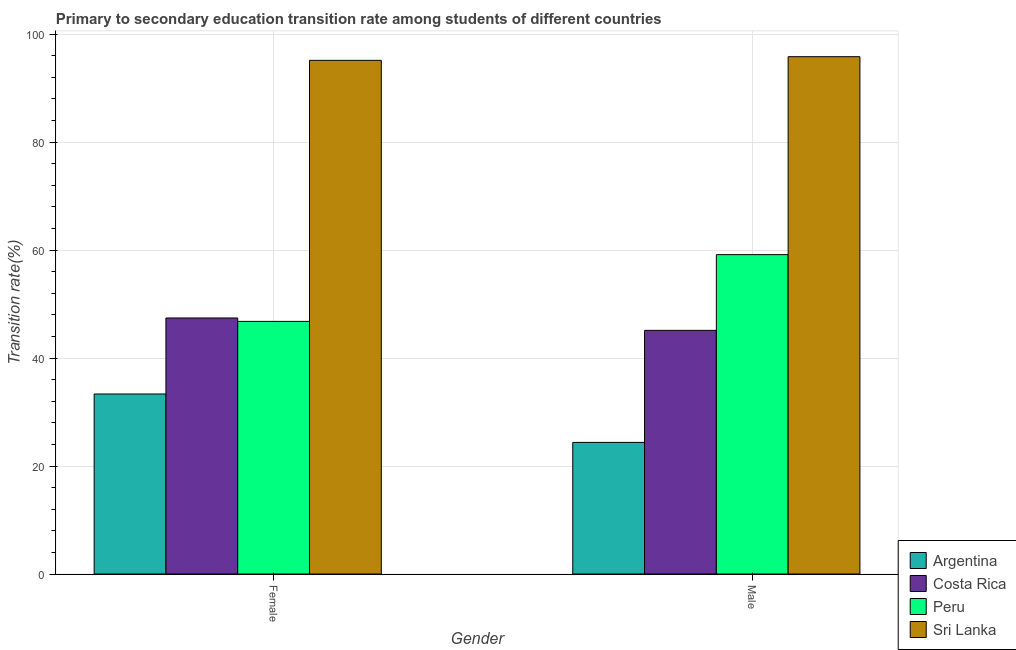How many groups of bars are there?
Give a very brief answer. 2. Are the number of bars per tick equal to the number of legend labels?
Your answer should be compact. Yes. How many bars are there on the 1st tick from the right?
Keep it short and to the point. 4. What is the label of the 2nd group of bars from the left?
Offer a terse response. Male. What is the transition rate among female students in Sri Lanka?
Make the answer very short. 95.13. Across all countries, what is the maximum transition rate among female students?
Offer a very short reply. 95.13. Across all countries, what is the minimum transition rate among female students?
Give a very brief answer. 33.34. In which country was the transition rate among male students maximum?
Provide a short and direct response. Sri Lanka. What is the total transition rate among male students in the graph?
Provide a succinct answer. 224.46. What is the difference between the transition rate among female students in Argentina and that in Sri Lanka?
Provide a short and direct response. -61.79. What is the difference between the transition rate among male students in Costa Rica and the transition rate among female students in Sri Lanka?
Keep it short and to the point. -50.01. What is the average transition rate among female students per country?
Offer a very short reply. 55.67. What is the difference between the transition rate among female students and transition rate among male students in Peru?
Give a very brief answer. -12.36. What is the ratio of the transition rate among male students in Sri Lanka to that in Costa Rica?
Your response must be concise. 2.12. In how many countries, is the transition rate among male students greater than the average transition rate among male students taken over all countries?
Keep it short and to the point. 2. How many bars are there?
Make the answer very short. 8. Are all the bars in the graph horizontal?
Your answer should be compact. No. How many countries are there in the graph?
Offer a very short reply. 4. Are the values on the major ticks of Y-axis written in scientific E-notation?
Make the answer very short. No. Does the graph contain grids?
Offer a very short reply. Yes. What is the title of the graph?
Give a very brief answer. Primary to secondary education transition rate among students of different countries. What is the label or title of the X-axis?
Provide a succinct answer. Gender. What is the label or title of the Y-axis?
Your answer should be compact. Transition rate(%). What is the Transition rate(%) in Argentina in Female?
Ensure brevity in your answer.  33.34. What is the Transition rate(%) of Costa Rica in Female?
Offer a very short reply. 47.42. What is the Transition rate(%) in Peru in Female?
Provide a short and direct response. 46.79. What is the Transition rate(%) in Sri Lanka in Female?
Provide a succinct answer. 95.13. What is the Transition rate(%) of Argentina in Male?
Your response must be concise. 24.38. What is the Transition rate(%) of Costa Rica in Male?
Provide a succinct answer. 45.13. What is the Transition rate(%) in Peru in Male?
Your answer should be compact. 59.15. What is the Transition rate(%) of Sri Lanka in Male?
Give a very brief answer. 95.81. Across all Gender, what is the maximum Transition rate(%) in Argentina?
Your response must be concise. 33.34. Across all Gender, what is the maximum Transition rate(%) of Costa Rica?
Make the answer very short. 47.42. Across all Gender, what is the maximum Transition rate(%) of Peru?
Offer a terse response. 59.15. Across all Gender, what is the maximum Transition rate(%) in Sri Lanka?
Keep it short and to the point. 95.81. Across all Gender, what is the minimum Transition rate(%) of Argentina?
Your answer should be very brief. 24.38. Across all Gender, what is the minimum Transition rate(%) of Costa Rica?
Ensure brevity in your answer.  45.13. Across all Gender, what is the minimum Transition rate(%) of Peru?
Provide a succinct answer. 46.79. Across all Gender, what is the minimum Transition rate(%) in Sri Lanka?
Your response must be concise. 95.13. What is the total Transition rate(%) in Argentina in the graph?
Your answer should be compact. 57.72. What is the total Transition rate(%) in Costa Rica in the graph?
Give a very brief answer. 92.54. What is the total Transition rate(%) in Peru in the graph?
Give a very brief answer. 105.94. What is the total Transition rate(%) in Sri Lanka in the graph?
Provide a succinct answer. 190.94. What is the difference between the Transition rate(%) in Argentina in Female and that in Male?
Make the answer very short. 8.96. What is the difference between the Transition rate(%) of Costa Rica in Female and that in Male?
Your response must be concise. 2.29. What is the difference between the Transition rate(%) of Peru in Female and that in Male?
Provide a short and direct response. -12.36. What is the difference between the Transition rate(%) in Sri Lanka in Female and that in Male?
Ensure brevity in your answer.  -0.68. What is the difference between the Transition rate(%) in Argentina in Female and the Transition rate(%) in Costa Rica in Male?
Offer a very short reply. -11.79. What is the difference between the Transition rate(%) of Argentina in Female and the Transition rate(%) of Peru in Male?
Offer a terse response. -25.81. What is the difference between the Transition rate(%) in Argentina in Female and the Transition rate(%) in Sri Lanka in Male?
Provide a succinct answer. -62.47. What is the difference between the Transition rate(%) in Costa Rica in Female and the Transition rate(%) in Peru in Male?
Give a very brief answer. -11.73. What is the difference between the Transition rate(%) in Costa Rica in Female and the Transition rate(%) in Sri Lanka in Male?
Make the answer very short. -48.39. What is the difference between the Transition rate(%) of Peru in Female and the Transition rate(%) of Sri Lanka in Male?
Offer a terse response. -49.02. What is the average Transition rate(%) of Argentina per Gender?
Offer a terse response. 28.86. What is the average Transition rate(%) of Costa Rica per Gender?
Keep it short and to the point. 46.27. What is the average Transition rate(%) in Peru per Gender?
Provide a short and direct response. 52.97. What is the average Transition rate(%) of Sri Lanka per Gender?
Offer a terse response. 95.47. What is the difference between the Transition rate(%) in Argentina and Transition rate(%) in Costa Rica in Female?
Keep it short and to the point. -14.08. What is the difference between the Transition rate(%) of Argentina and Transition rate(%) of Peru in Female?
Keep it short and to the point. -13.45. What is the difference between the Transition rate(%) in Argentina and Transition rate(%) in Sri Lanka in Female?
Provide a short and direct response. -61.79. What is the difference between the Transition rate(%) of Costa Rica and Transition rate(%) of Peru in Female?
Make the answer very short. 0.63. What is the difference between the Transition rate(%) of Costa Rica and Transition rate(%) of Sri Lanka in Female?
Your answer should be very brief. -47.72. What is the difference between the Transition rate(%) of Peru and Transition rate(%) of Sri Lanka in Female?
Offer a very short reply. -48.35. What is the difference between the Transition rate(%) of Argentina and Transition rate(%) of Costa Rica in Male?
Give a very brief answer. -20.75. What is the difference between the Transition rate(%) in Argentina and Transition rate(%) in Peru in Male?
Keep it short and to the point. -34.77. What is the difference between the Transition rate(%) of Argentina and Transition rate(%) of Sri Lanka in Male?
Keep it short and to the point. -71.43. What is the difference between the Transition rate(%) in Costa Rica and Transition rate(%) in Peru in Male?
Make the answer very short. -14.02. What is the difference between the Transition rate(%) in Costa Rica and Transition rate(%) in Sri Lanka in Male?
Provide a short and direct response. -50.68. What is the difference between the Transition rate(%) in Peru and Transition rate(%) in Sri Lanka in Male?
Your answer should be compact. -36.66. What is the ratio of the Transition rate(%) of Argentina in Female to that in Male?
Keep it short and to the point. 1.37. What is the ratio of the Transition rate(%) in Costa Rica in Female to that in Male?
Make the answer very short. 1.05. What is the ratio of the Transition rate(%) in Peru in Female to that in Male?
Give a very brief answer. 0.79. What is the ratio of the Transition rate(%) of Sri Lanka in Female to that in Male?
Provide a short and direct response. 0.99. What is the difference between the highest and the second highest Transition rate(%) in Argentina?
Your answer should be very brief. 8.96. What is the difference between the highest and the second highest Transition rate(%) of Costa Rica?
Offer a very short reply. 2.29. What is the difference between the highest and the second highest Transition rate(%) in Peru?
Make the answer very short. 12.36. What is the difference between the highest and the second highest Transition rate(%) in Sri Lanka?
Your answer should be compact. 0.68. What is the difference between the highest and the lowest Transition rate(%) in Argentina?
Your answer should be compact. 8.96. What is the difference between the highest and the lowest Transition rate(%) in Costa Rica?
Your answer should be compact. 2.29. What is the difference between the highest and the lowest Transition rate(%) in Peru?
Your answer should be compact. 12.36. What is the difference between the highest and the lowest Transition rate(%) in Sri Lanka?
Your answer should be compact. 0.68. 